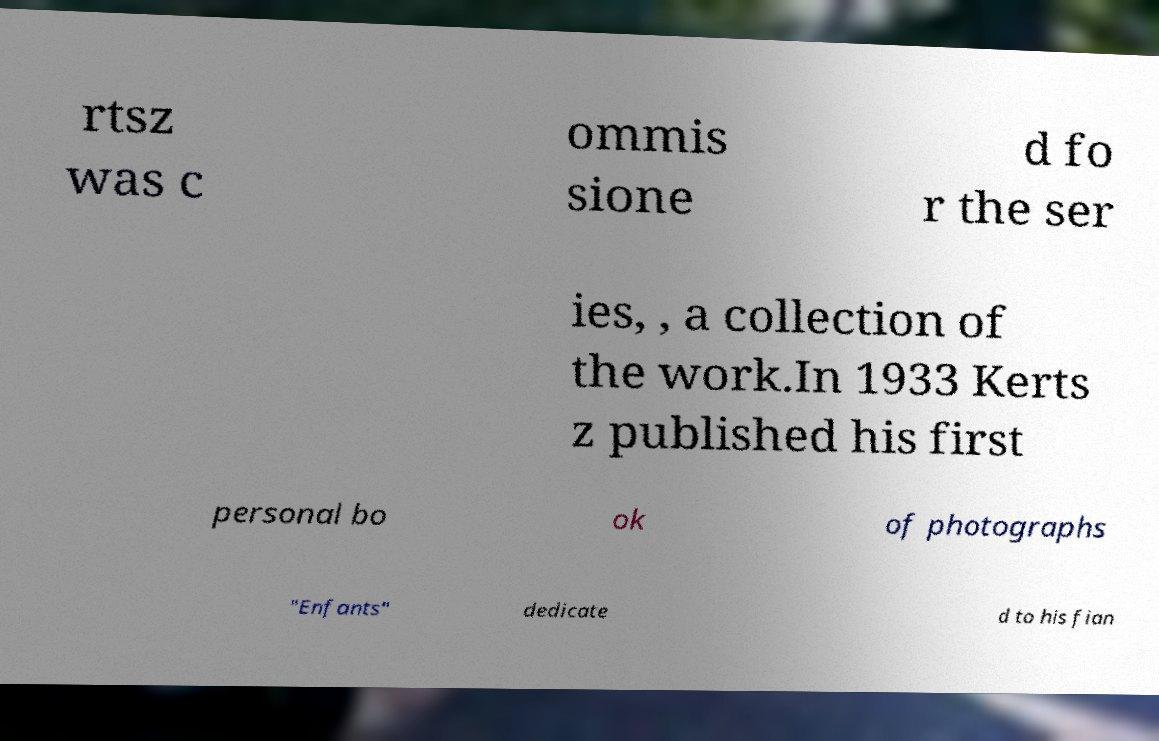For documentation purposes, I need the text within this image transcribed. Could you provide that? rtsz was c ommis sione d fo r the ser ies, , a collection of the work.In 1933 Kerts z published his first personal bo ok of photographs "Enfants" dedicate d to his fian 